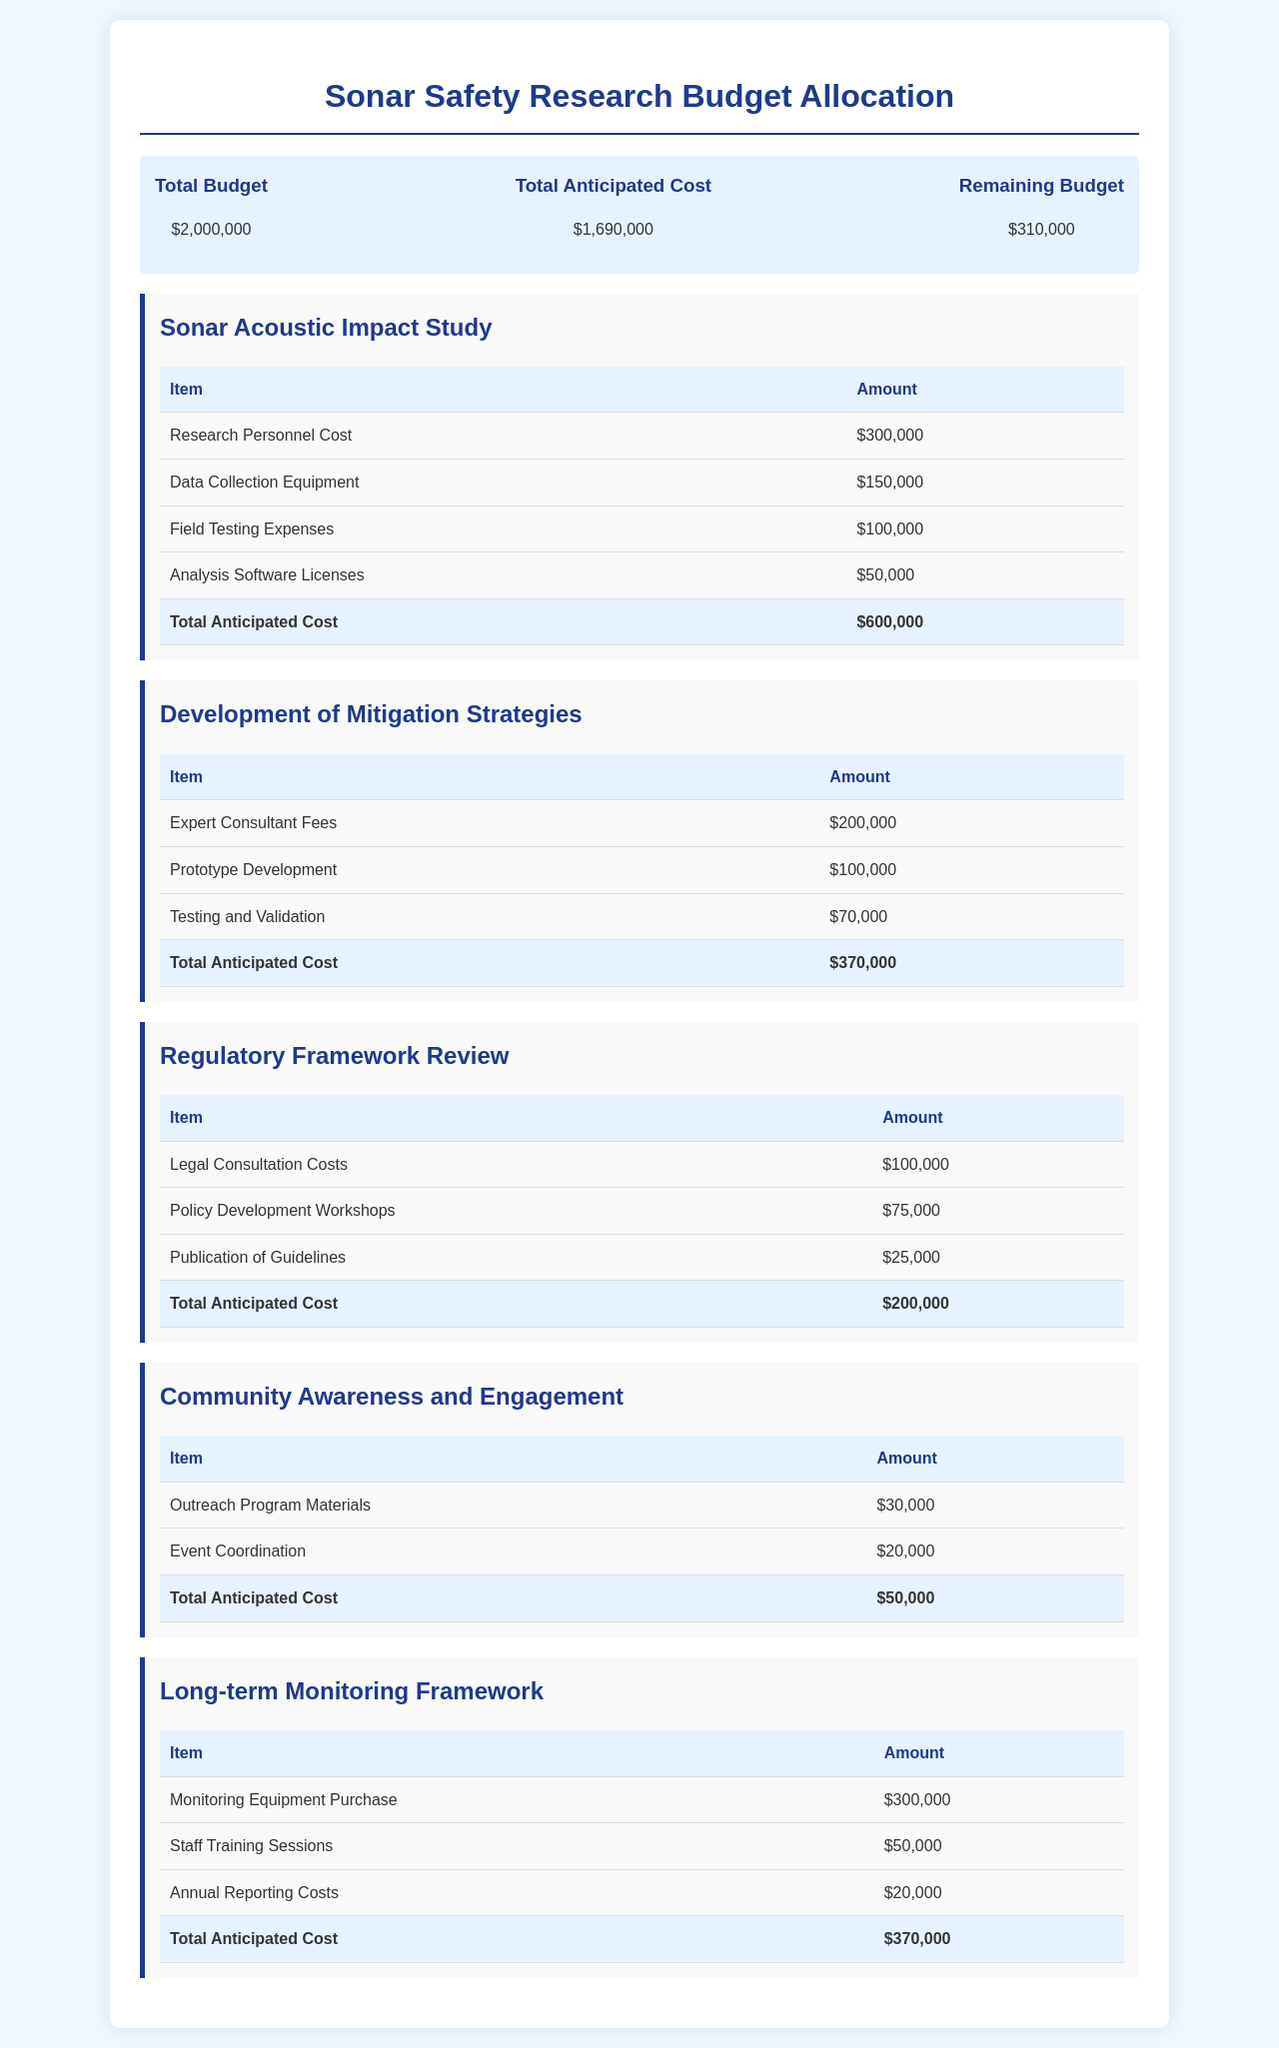what is the total budget? The total budget is the overall fiscal allocation for the projects listed in the document.
Answer: $2,000,000 what is the total anticipated cost for the Sonar Acoustic Impact Study? This cost is derived from the total expenses outlined in the respective project table.
Answer: $600,000 how much is allocated for the Outreach Program Materials in the Community Awareness and Engagement project? This is a specific line item cost listed in the project's budget table.
Answer: $30,000 what is the remaining budget after accounting for all anticipated costs? The remaining budget is the difference between the total budget and the total anticipated cost.
Answer: $310,000 which project has the highest anticipated cost? This requires comparing the total anticipated costs of each listed project in the document.
Answer: Sonar Acoustic Impact Study what is the total anticipated cost for the Development of Mitigation Strategies? The total for this project is summed from all individual expenses listed in the project's section.
Answer: $370,000 how many projects are detailed in the budget allocation? This answer includes counting all distinct project sections in the document.
Answer: 5 what is the anticipated cost for the Publication of Guidelines under the Regulatory Framework Review? This is a specific expenditure item noted in the corresponding project budget.
Answer: $25,000 who incurs the Legal Consultation Costs in the Regulatory Framework Review? This refers to the nature of the costs listed in the budget and may relate to professionals hired for legal advice.
Answer: $100,000 